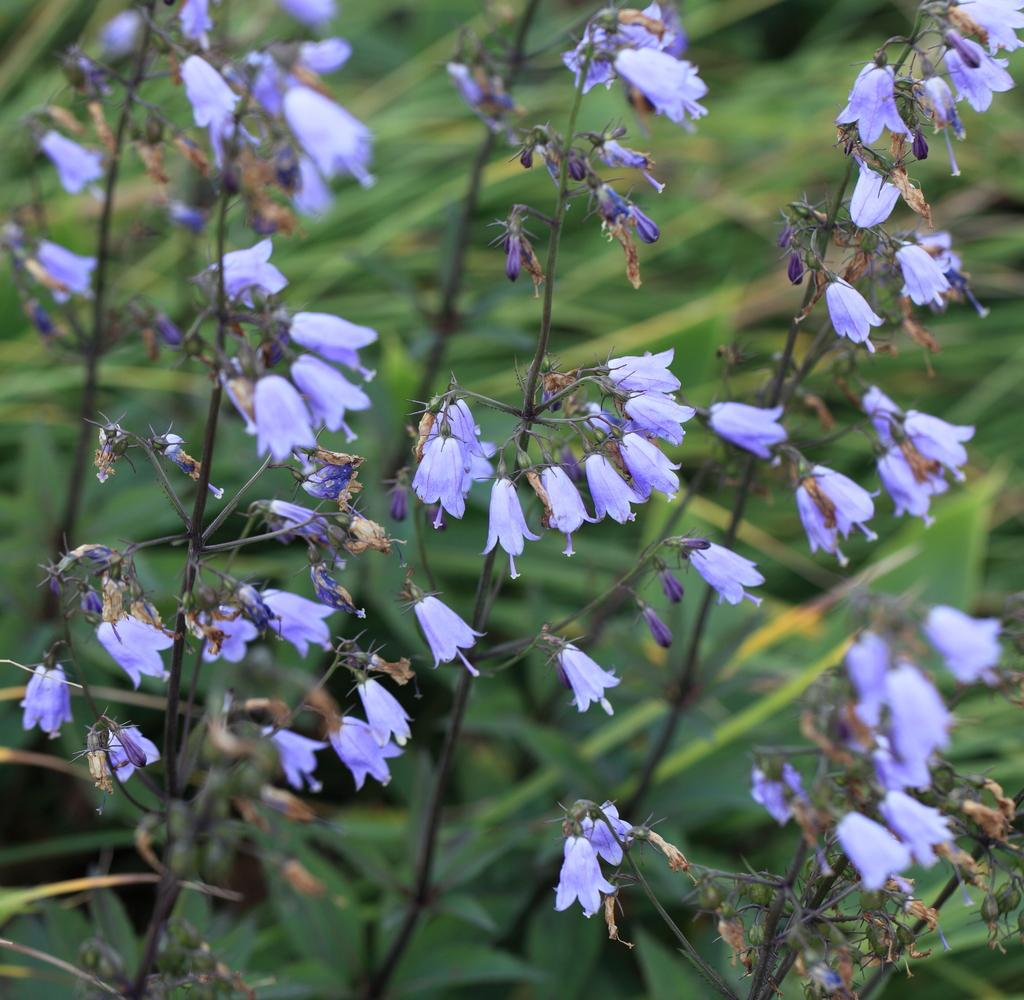What type of living organisms can be seen in the image? There are flowers in the image. What are the flowers growing on? The flowers are on plants. Where are the plants located in the image? The plants are in the center of the image. What type of sticks can be seen holding up the flowers in the image? There are no sticks visible in the image; the flowers are on plants. 